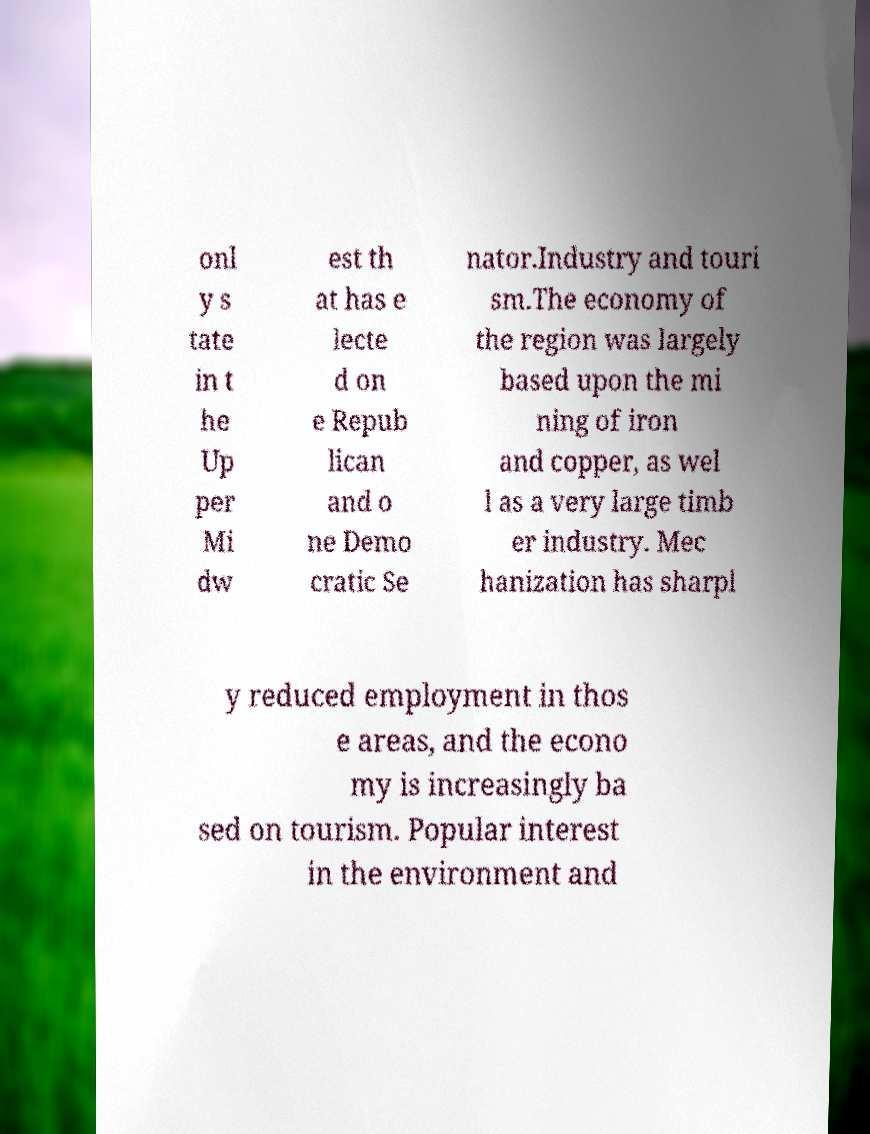What messages or text are displayed in this image? I need them in a readable, typed format. onl y s tate in t he Up per Mi dw est th at has e lecte d on e Repub lican and o ne Demo cratic Se nator.Industry and touri sm.The economy of the region was largely based upon the mi ning of iron and copper, as wel l as a very large timb er industry. Mec hanization has sharpl y reduced employment in thos e areas, and the econo my is increasingly ba sed on tourism. Popular interest in the environment and 